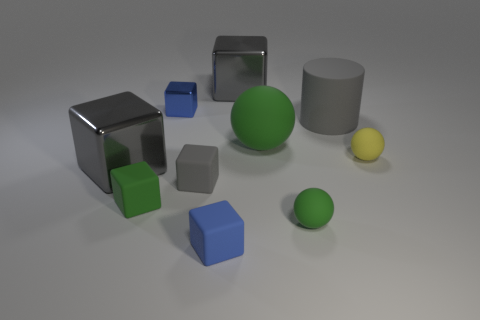Subtract all green matte cubes. How many cubes are left? 5 Subtract all blue blocks. How many blocks are left? 4 Subtract 3 spheres. How many spheres are left? 0 Subtract all blue cylinders. How many gray cubes are left? 3 Subtract all cylinders. How many objects are left? 9 Add 8 gray rubber cubes. How many gray rubber cubes are left? 9 Add 1 balls. How many balls exist? 4 Subtract 0 brown spheres. How many objects are left? 10 Subtract all brown cylinders. Subtract all brown blocks. How many cylinders are left? 1 Subtract all big rubber objects. Subtract all brown shiny cylinders. How many objects are left? 8 